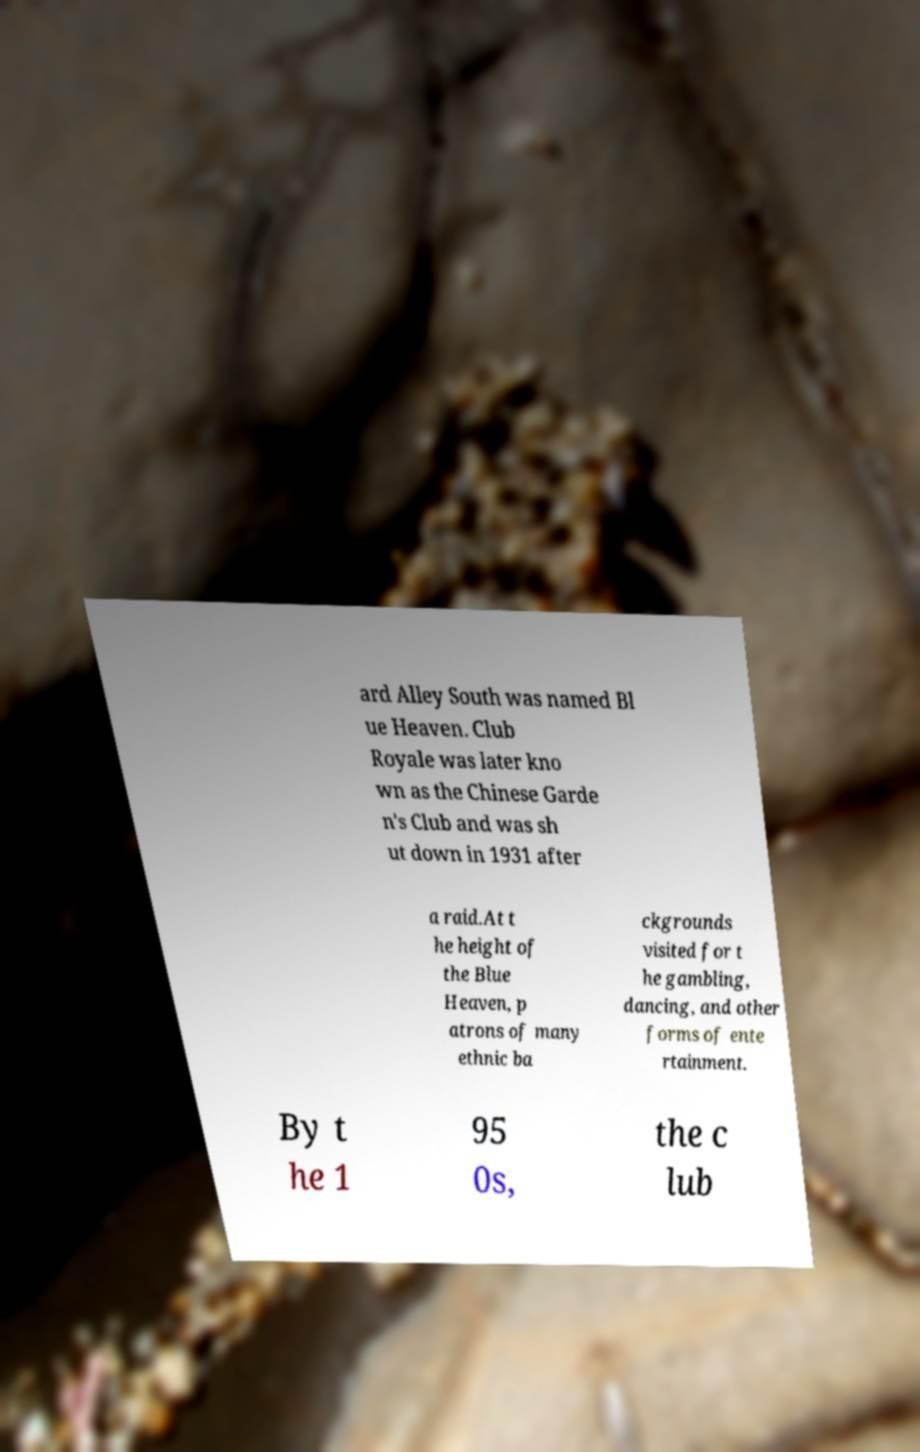I need the written content from this picture converted into text. Can you do that? ard Alley South was named Bl ue Heaven. Club Royale was later kno wn as the Chinese Garde n's Club and was sh ut down in 1931 after a raid.At t he height of the Blue Heaven, p atrons of many ethnic ba ckgrounds visited for t he gambling, dancing, and other forms of ente rtainment. By t he 1 95 0s, the c lub 